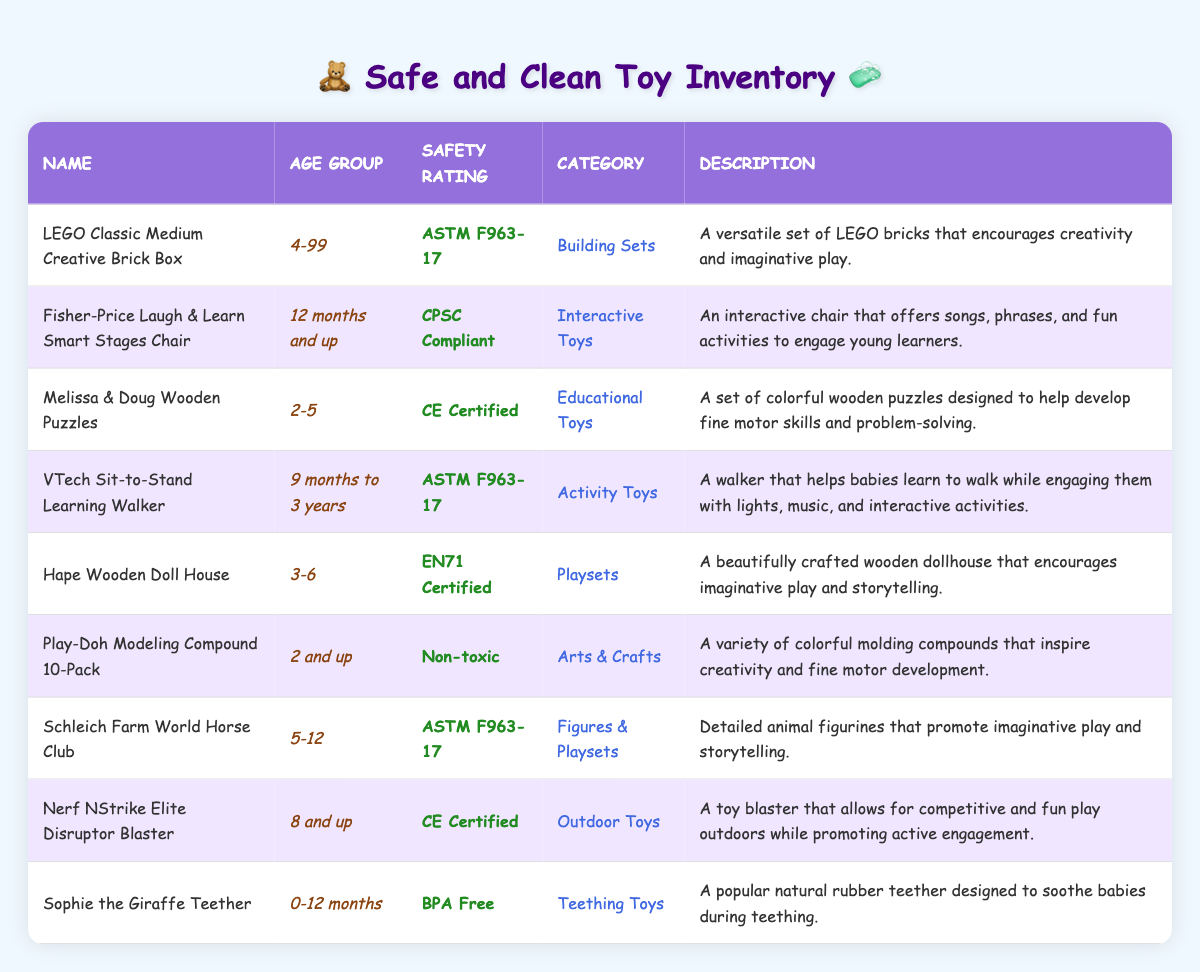What are the safety ratings for toys suitable for children aged 2-5? The toys categorized for children aged 2-5 are "Melissa & Doug Wooden Puzzles" with a safety rating of CE Certified and "Play-Doh Modeling Compound 10-Pack" with a safety rating of Non-toxic. These are the only toys listed that fall within that age group.
Answer: CE Certified and Non-toxic Which toy has the highest age range suitable for play? The "LEGO Classic Medium Creative Brick Box" is suitable for ages 4-99, which covers the broadest age range of all toys in the inventory. This range indicates that it can be used by both children and adults.
Answer: LEGO Classic Medium Creative Brick Box Is there any toy that is suitable for infants under 12 months? Yes, "Sophie the Giraffe Teether" is specifically designed for infants aged 0-12 months, making it appropriate for very young children.
Answer: Yes How many toys in the inventory are rated as ASTM F963-17? There are three toys with the safety rating ASTM F963-17: "LEGO Classic Medium Creative Brick Box," "VTech Sit-to-Stand Learning Walker," and "Schleich Farm World Horse Club." By counting them, the answer is 3.
Answer: 3 Which category of toys has a safety rating of CPSC Compliant? The "Fisher-Price Laugh & Learn Smart Stages Chair" is the only toy listed in the inventory that has a safety rating of CPSC Compliant, as indicated in the table.
Answer: Interactive Toys How many toys are suitable for children aged 3-6? The toys suitable for children aged 3-6 are "Hape Wooden Doll House" and "VTech Sit-to-Stand Learning Walker." By counting these toys, a total of 1 toy matches this age group.
Answer: 1 Which age group has the most toys listed in the inventory? The age group "5-12" includes "Schleich Farm World Horse Club," while the "2-5" and "3-6" groups have two toys each. By observing the counts, it's inferred that the "2-5" group collectively has four toys, which is the most of any specified age group.
Answer: 3-6 (4 toys) Are all toys in the inventory marked as non-toxic? No, not all toys are marked as non-toxic; only the "Play-Doh Modeling Compound 10-Pack" has the non-toxic rating. The others have various different safety ratings listed.
Answer: No 